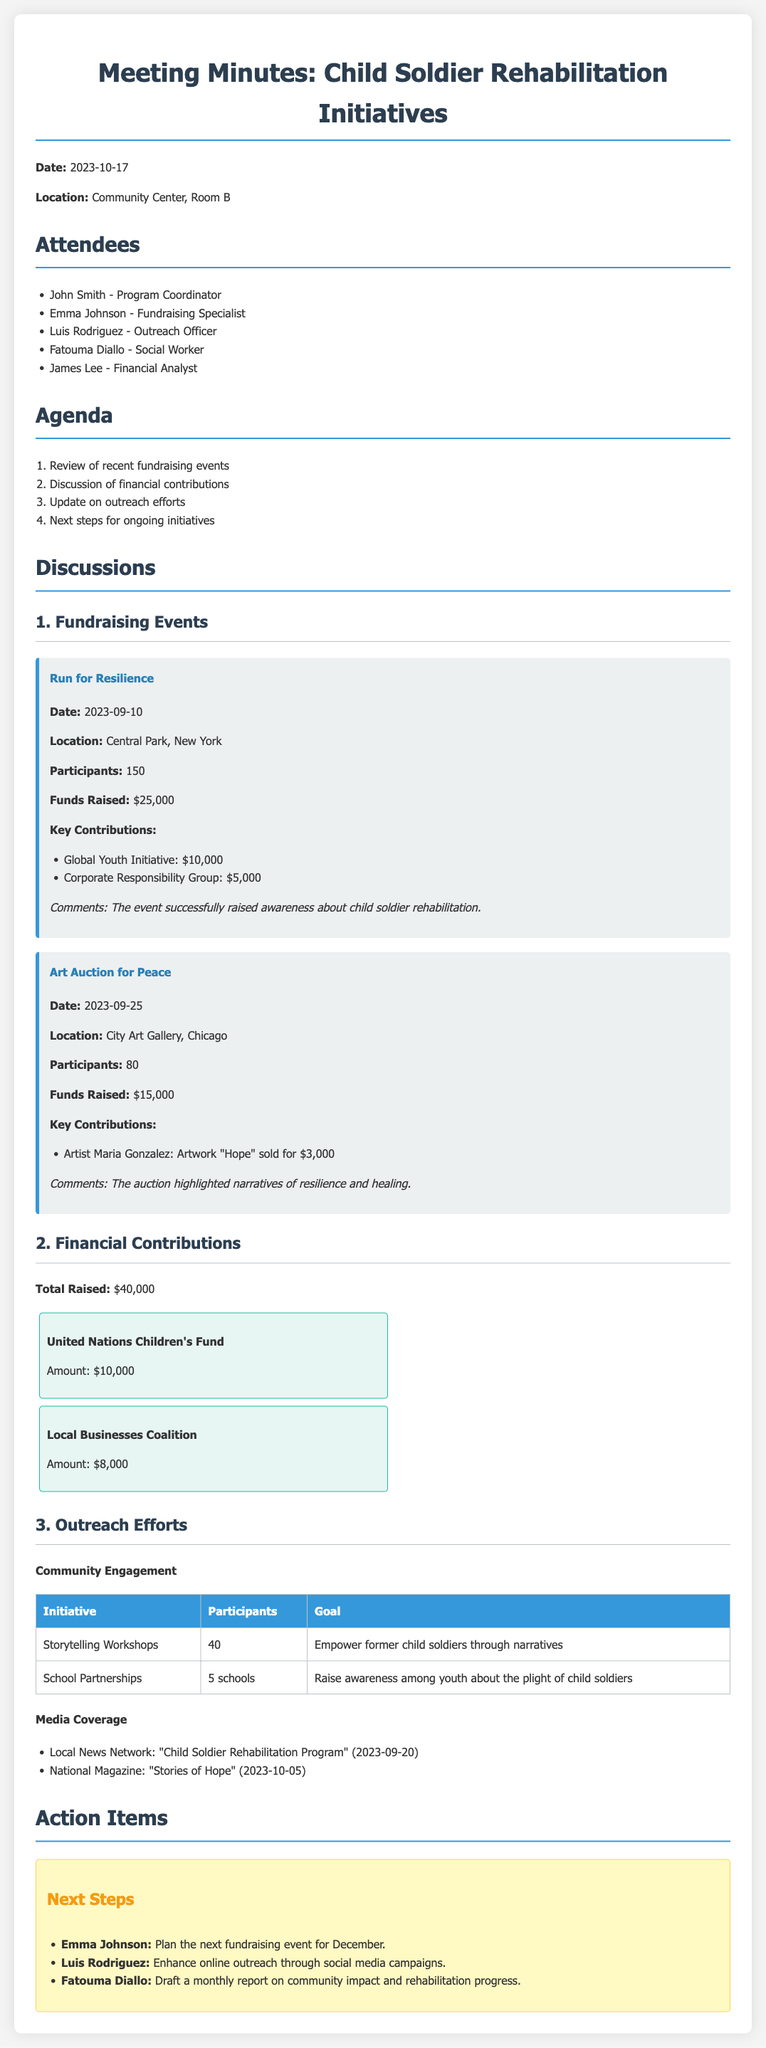What is the date of the meeting? The date of the meeting is explicitly stated in the document.
Answer: 2023-10-17 Who is the Fundraising Specialist? The document lists attendees, including their roles.
Answer: Emma Johnson How much did the Run for Resilience event raise? The amount is specified under the fundraising events section.
Answer: $25,000 What is the total amount raised from all events? The total amount raised is summarized in the financial contributions section.
Answer: $40,000 How many participants were at the Art Auction for Peace? The number of participants is noted for each event.
Answer: 80 What is the goal of the Storytelling Workshops? The goal is provided in the outreach efforts section for each initiative.
Answer: Empower former child soldiers through narratives What are the next steps planned by Emma Johnson? The action items specify tasks assigned to different attendees.
Answer: Plan the next fundraising event for December What was highlighted by the Art Auction for Peace? The auction's comments hint at its focus and impact.
Answer: Narratives of resilience and healing 